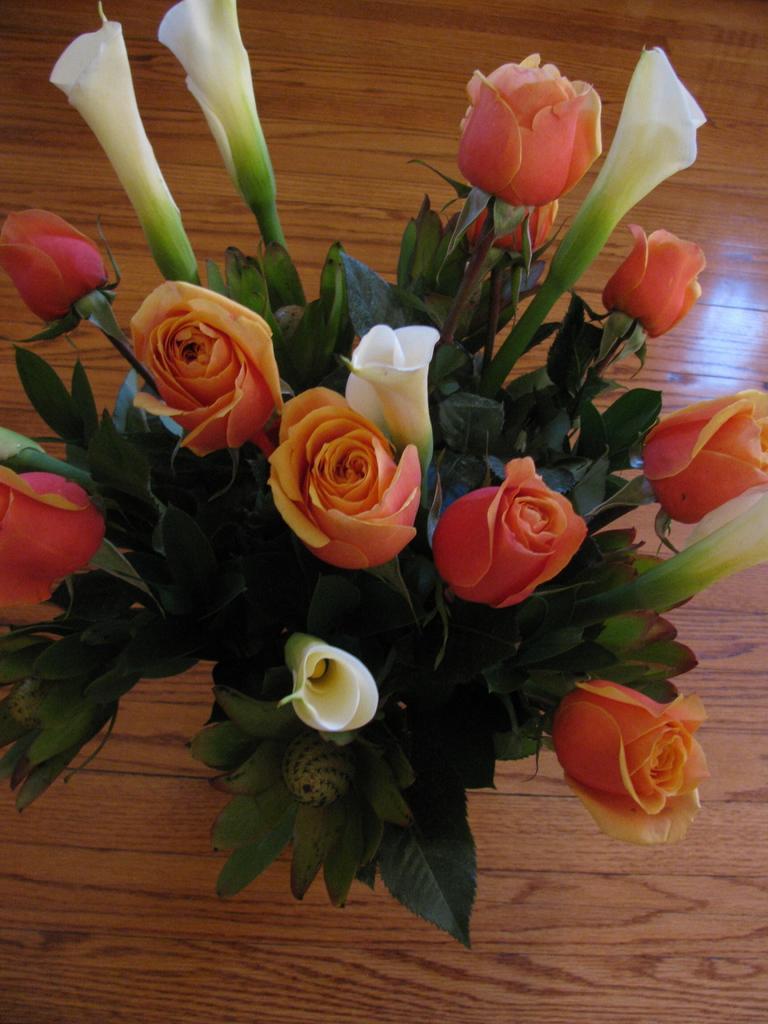Can you describe this image briefly? In this image we can see the flowers and also the leaves. In the background, we can see the wooden surface. 